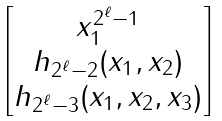<formula> <loc_0><loc_0><loc_500><loc_500>\begin{bmatrix} x _ { 1 } ^ { 2 ^ { \ell } - 1 } \\ h _ { 2 ^ { \ell } - 2 } ( x _ { 1 } , x _ { 2 } ) \\ h _ { 2 ^ { \ell } - 3 } ( x _ { 1 } , x _ { 2 } , x _ { 3 } ) \end{bmatrix}</formula> 